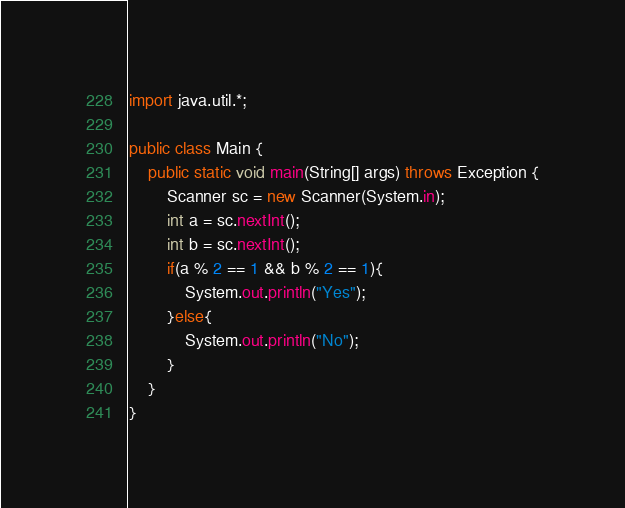<code> <loc_0><loc_0><loc_500><loc_500><_Java_>import java.util.*;

public class Main {
    public static void main(String[] args) throws Exception {
        Scanner sc = new Scanner(System.in);
        int a = sc.nextInt();
        int b = sc.nextInt();
        if(a % 2 == 1 && b % 2 == 1){
            System.out.println("Yes");
        }else{
            System.out.println("No");
        }
    }
}
</code> 